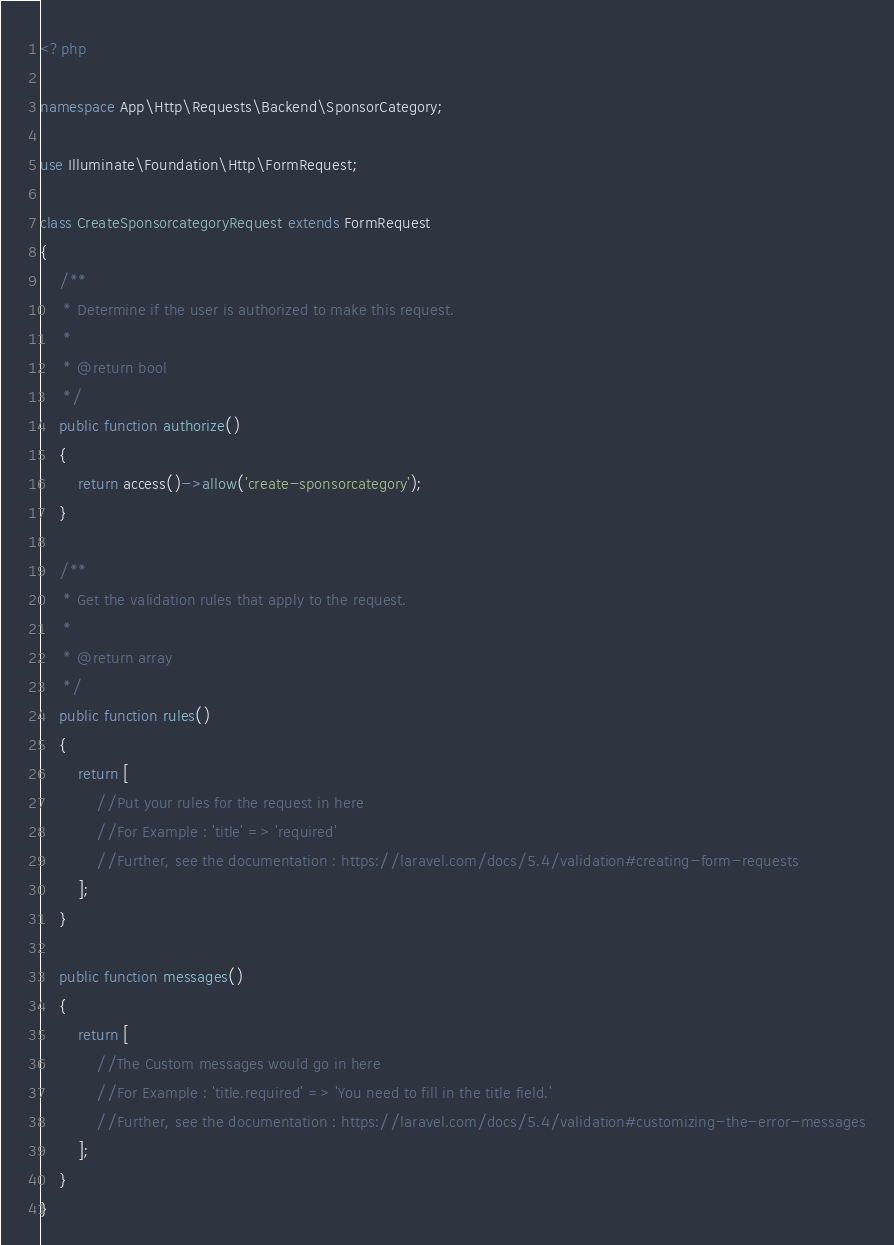<code> <loc_0><loc_0><loc_500><loc_500><_PHP_><?php

namespace App\Http\Requests\Backend\SponsorCategory;

use Illuminate\Foundation\Http\FormRequest;

class CreateSponsorcategoryRequest extends FormRequest
{
    /**
     * Determine if the user is authorized to make this request.
     *
     * @return bool
     */
    public function authorize()
    {
        return access()->allow('create-sponsorcategory');
    }

    /**
     * Get the validation rules that apply to the request.
     *
     * @return array
     */
    public function rules()
    {
        return [
            //Put your rules for the request in here
            //For Example : 'title' => 'required'
            //Further, see the documentation : https://laravel.com/docs/5.4/validation#creating-form-requests
        ];
    }

    public function messages()
    {
        return [
            //The Custom messages would go in here
            //For Example : 'title.required' => 'You need to fill in the title field.'
            //Further, see the documentation : https://laravel.com/docs/5.4/validation#customizing-the-error-messages
        ];
    }
}
</code> 